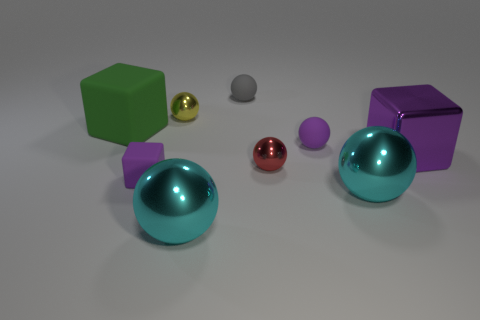What number of rubber objects are either large green things or cyan balls?
Provide a succinct answer. 1. Do the large rubber cube and the small cube have the same color?
Your answer should be very brief. No. How many tiny purple objects are behind the tiny cube?
Your answer should be compact. 1. What number of things are in front of the small red thing and to the right of the yellow metal sphere?
Provide a short and direct response. 2. What shape is the large green thing that is the same material as the tiny cube?
Your answer should be very brief. Cube. Is the size of the gray matte ball behind the red metallic ball the same as the cube that is right of the yellow object?
Give a very brief answer. No. What is the color of the small matte ball that is behind the purple ball?
Provide a succinct answer. Gray. What is the big block that is left of the small purple thing right of the small purple block made of?
Your response must be concise. Rubber. The gray rubber object is what shape?
Provide a short and direct response. Sphere. There is a yellow object that is the same shape as the tiny red shiny object; what material is it?
Provide a short and direct response. Metal. 